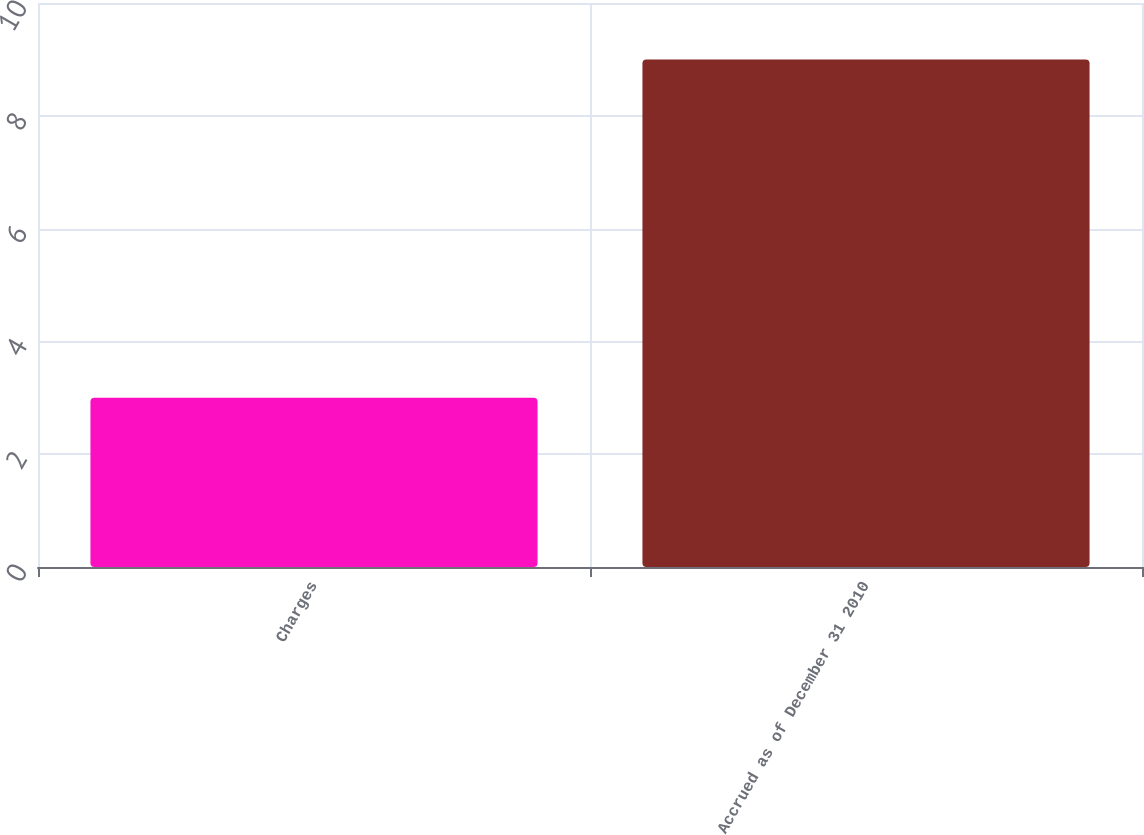Convert chart to OTSL. <chart><loc_0><loc_0><loc_500><loc_500><bar_chart><fcel>Charges<fcel>Accrued as of December 31 2010<nl><fcel>3<fcel>9<nl></chart> 